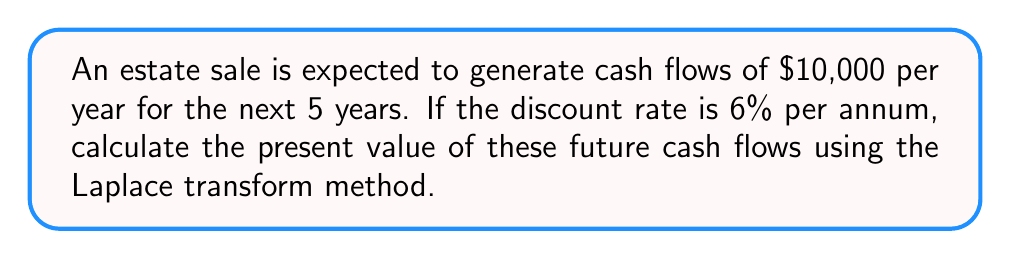Can you answer this question? To solve this problem using the Laplace transform method, we'll follow these steps:

1) First, let's define our cash flow function. Since we have constant cash flows of $10,000 per year for 5 years, our function is:

   $$f(t) = \begin{cases} 
   10000, & 0 \leq t < 5 \\
   0, & t \geq 5
   \end{cases}$$

2) The Laplace transform of this function is:

   $$F(s) = \int_0^5 10000e^{-st} dt$$

3) Solving this integral:

   $$F(s) = 10000 \left[-\frac{1}{s}e^{-st}\right]_0^5 = \frac{10000}{s}(1-e^{-5s})$$

4) The present value is given by $F(r)$, where $r$ is the discount rate. In this case, $r = 0.06$.

5) Substituting $s = 0.06$ into our $F(s)$:

   $$F(0.06) = \frac{10000}{0.06}(1-e^{-5(0.06)})$$

6) Simplifying:

   $$F(0.06) = 166666.67(1-e^{-0.3})$$
   $$F(0.06) = 166666.67(1-0.7408)$$
   $$F(0.06) = 166666.67(0.2592)$$
   $$F(0.06) = 43200$$

Therefore, the present value of the future cash flows is $43,200.
Answer: $43,200 